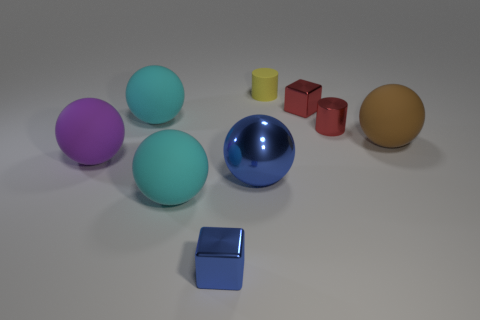Subtract all metal balls. How many balls are left? 4 Subtract all blue balls. How many balls are left? 4 Subtract all cubes. How many objects are left? 7 Add 1 shiny cylinders. How many objects exist? 10 Subtract all purple balls. How many yellow cylinders are left? 1 Subtract all large blocks. Subtract all large brown rubber balls. How many objects are left? 8 Add 1 small yellow rubber cylinders. How many small yellow rubber cylinders are left? 2 Add 1 red matte spheres. How many red matte spheres exist? 1 Subtract 0 purple cylinders. How many objects are left? 9 Subtract 4 balls. How many balls are left? 1 